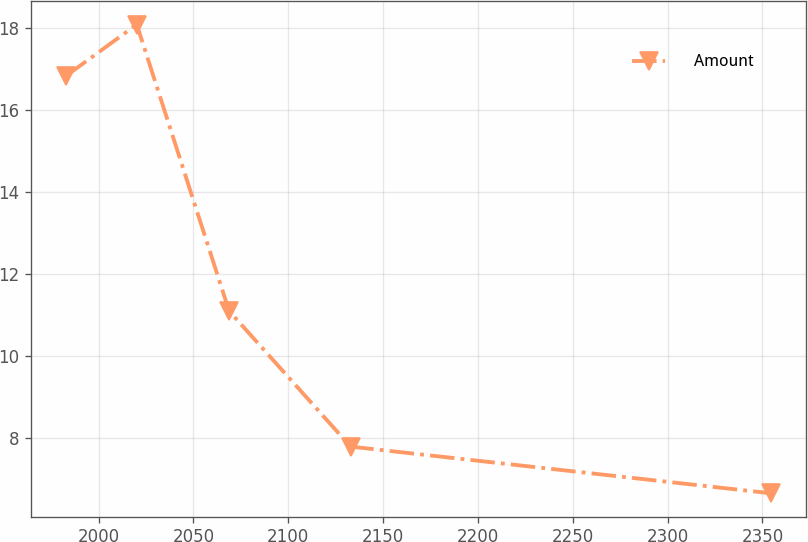Convert chart to OTSL. <chart><loc_0><loc_0><loc_500><loc_500><line_chart><ecel><fcel>Amount<nl><fcel>1982.99<fcel>16.84<nl><fcel>2020.15<fcel>18.09<nl><fcel>2068.81<fcel>11.1<nl><fcel>2132.9<fcel>7.79<nl><fcel>2354.6<fcel>6.65<nl></chart> 